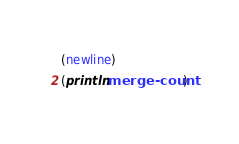<code> <loc_0><loc_0><loc_500><loc_500><_Scheme_>(newline)
(println merge-count)
</code> 